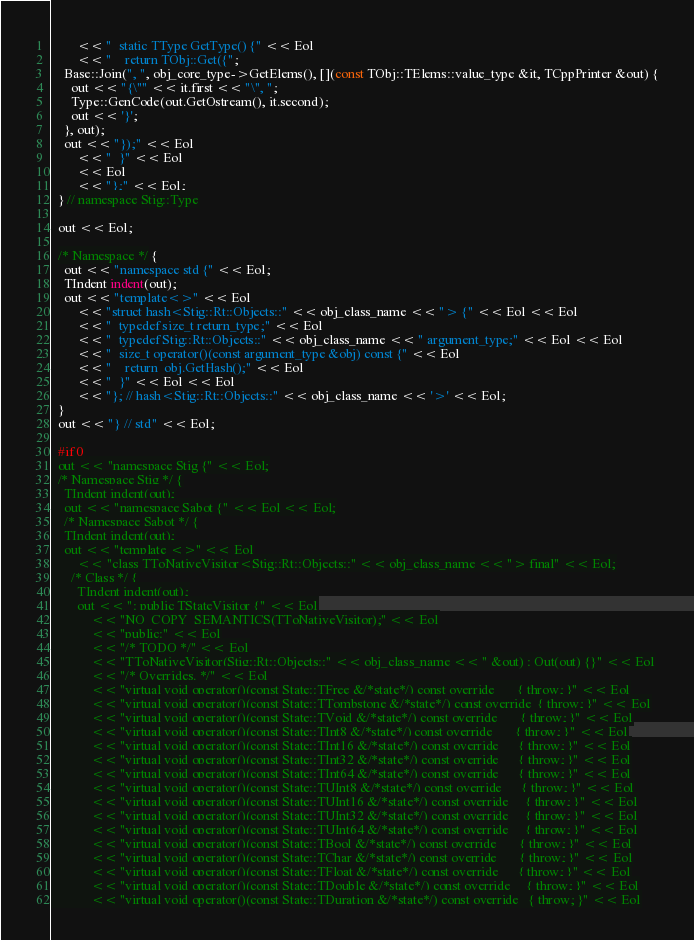<code> <loc_0><loc_0><loc_500><loc_500><_C++_>        << "  static TType GetType() {" << Eol
        << "    return TObj::Get({";
    Base::Join(", ", obj_core_type->GetElems(), [](const TObj::TElems::value_type &it, TCppPrinter &out) {
      out << "{\"" << it.first << "\", ";
      Type::GenCode(out.GetOstream(), it.second);
      out << '}';
    }, out);
    out << "});" << Eol
        << "  }" << Eol
        << Eol
        << "};" << Eol;
  } // namespace Stig::Type

  out << Eol;

  /* Namespace */ {
    out << "namespace std {" << Eol;
    TIndent indent(out);
    out << "template<>" << Eol
        << "struct hash<Stig::Rt::Objects::" << obj_class_name << "> {" << Eol << Eol
        << "  typedef size_t return_type;" << Eol
        << "  typedef Stig::Rt::Objects::" << obj_class_name << " argument_type;" << Eol << Eol
        << "  size_t operator()(const argument_type &obj) const {" << Eol
        << "    return  obj.GetHash();" << Eol
        << "  }" << Eol << Eol
        << "}; // hash<Stig::Rt::Objects::" << obj_class_name << '>' << Eol;
  }
  out << "} // std" << Eol;

  #if 0
  out << "namespace Stig {" << Eol;
  /* Namespace Stig */ {
    TIndent indent(out);
    out << "namespace Sabot {" << Eol << Eol;
    /* Namespace Sabot */ {
    TIndent indent(out);
    out << "template <>" << Eol
        << "class TToNativeVisitor<Stig::Rt::Objects::" << obj_class_name << "> final" << Eol;
      /* Class */ {
        TIndent indent(out);
        out << ": public TStateVisitor {" << Eol
            << "NO_COPY_SEMANTICS(TToNativeVisitor);" << Eol
            << "public:" << Eol
            << "/* TODO */" << Eol
            << "TToNativeVisitor(Stig::Rt::Objects::" << obj_class_name << " &out) : Out(out) {}" << Eol
            << "/* Overrides. */" << Eol
            << "virtual void operator()(const State::TFree &/*state*/) const override       { throw; }" << Eol
            << "virtual void operator()(const State::TTombstone &/*state*/) const override  { throw; }" << Eol
            << "virtual void operator()(const State::TVoid &/*state*/) const override       { throw; }" << Eol
            << "virtual void operator()(const State::TInt8 &/*state*/) const override       { throw; }" << Eol
            << "virtual void operator()(const State::TInt16 &/*state*/) const override      { throw; }" << Eol
            << "virtual void operator()(const State::TInt32 &/*state*/) const override      { throw; }" << Eol
            << "virtual void operator()(const State::TInt64 &/*state*/) const override      { throw; }" << Eol
            << "virtual void operator()(const State::TUInt8 &/*state*/) const override      { throw; }" << Eol
            << "virtual void operator()(const State::TUInt16 &/*state*/) const override     { throw; }" << Eol
            << "virtual void operator()(const State::TUInt32 &/*state*/) const override     { throw; }" << Eol
            << "virtual void operator()(const State::TUInt64 &/*state*/) const override     { throw; }" << Eol
            << "virtual void operator()(const State::TBool &/*state*/) const override       { throw; }" << Eol
            << "virtual void operator()(const State::TChar &/*state*/) const override       { throw; }" << Eol
            << "virtual void operator()(const State::TFloat &/*state*/) const override      { throw; }" << Eol
            << "virtual void operator()(const State::TDouble &/*state*/) const override     { throw; }" << Eol
            << "virtual void operator()(const State::TDuration &/*state*/) const override   { throw; }" << Eol</code> 